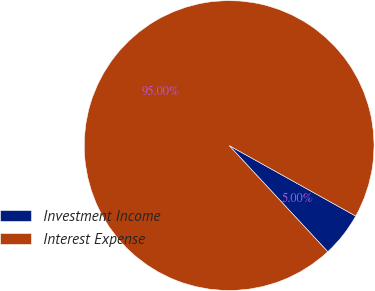<chart> <loc_0><loc_0><loc_500><loc_500><pie_chart><fcel>Investment Income<fcel>Interest Expense<nl><fcel>5.0%<fcel>95.0%<nl></chart> 